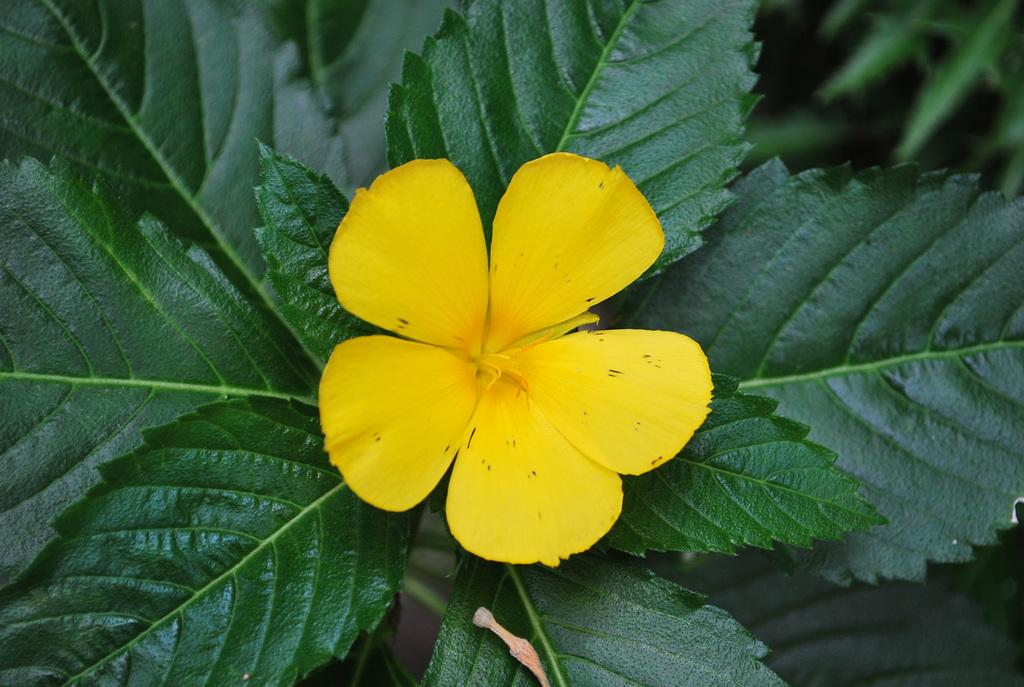What is the main subject of the image? The main subject of the image is a flower. Is the flower part of a larger plant? Yes, the flower is attached to a plant. What else can be seen in the image besides the flower? Leaves are visible in the image. What type of spy equipment can be seen hidden among the leaves in the image? There is no spy equipment present in the image; it features a flower, plant, and leaves. 